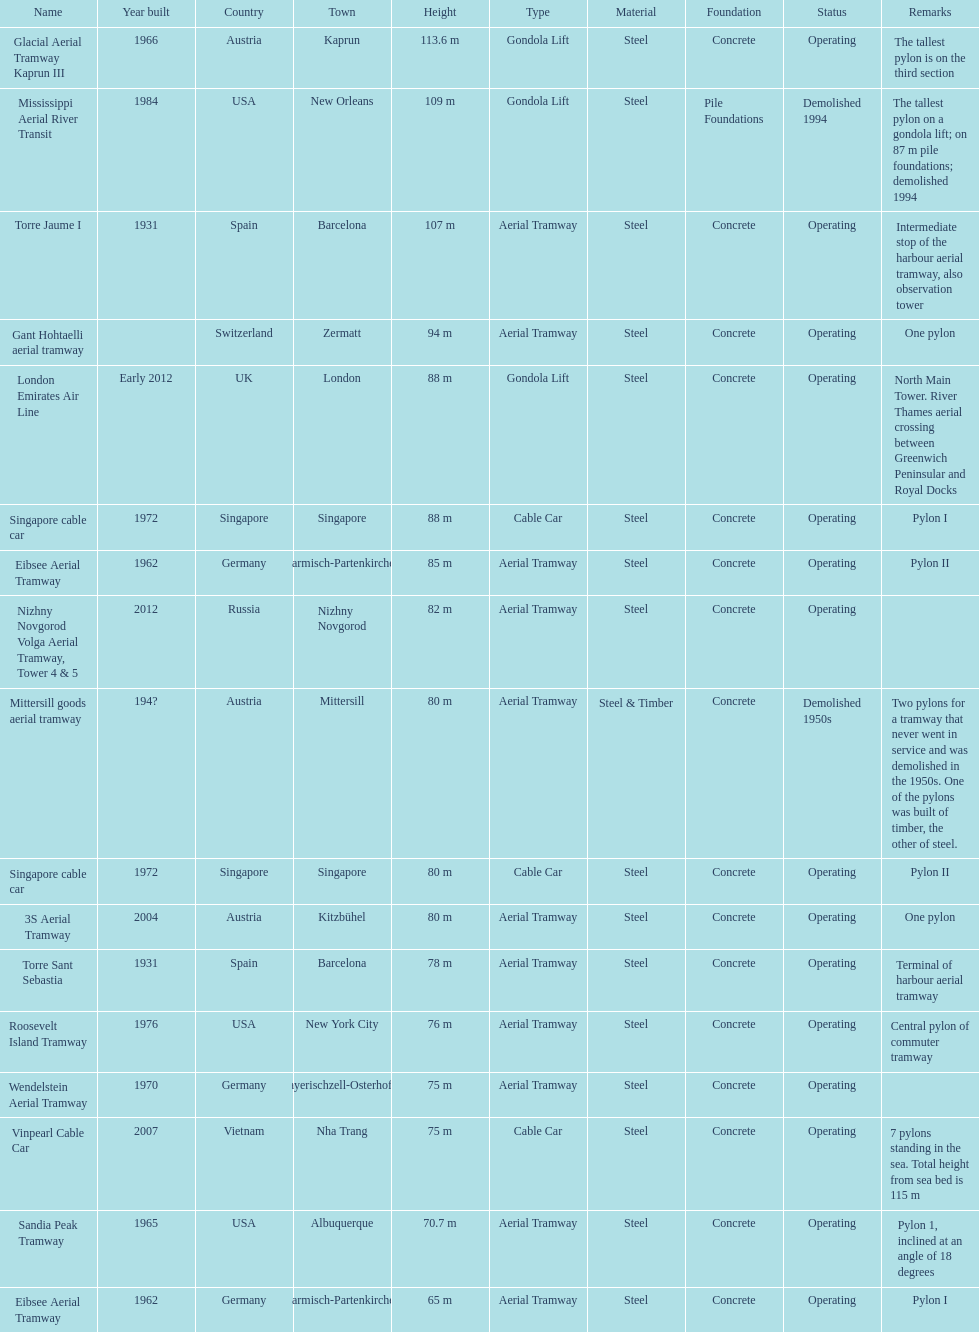List two pylons that are at most, 80 m in height. Mittersill goods aerial tramway, Singapore cable car. 